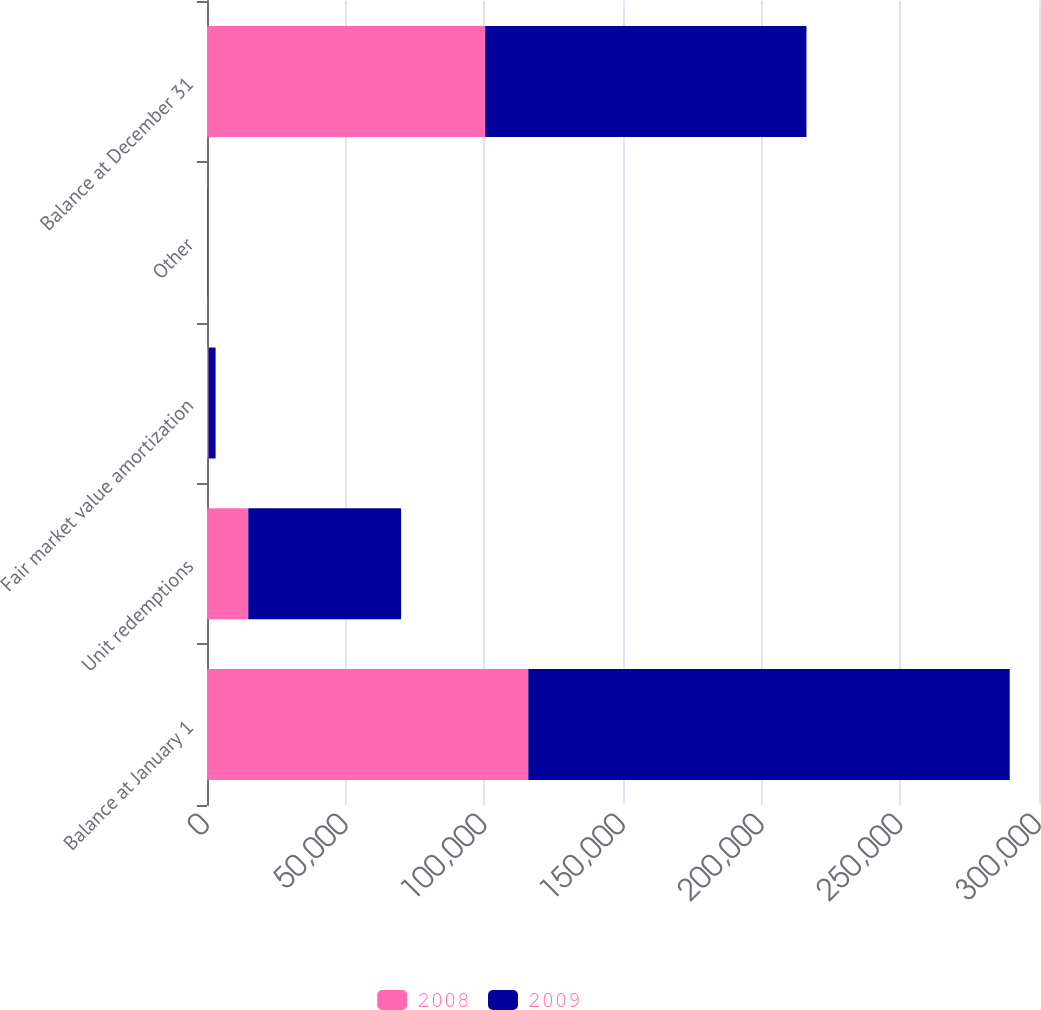Convert chart. <chart><loc_0><loc_0><loc_500><loc_500><stacked_bar_chart><ecel><fcel>Balance at January 1<fcel>Unit redemptions<fcel>Fair market value amortization<fcel>Other<fcel>Balance at December 31<nl><fcel>2008<fcel>115853<fcel>14889<fcel>571<fcel>89<fcel>100304<nl><fcel>2009<fcel>173592<fcel>55110<fcel>2524<fcel>105<fcel>115853<nl></chart> 